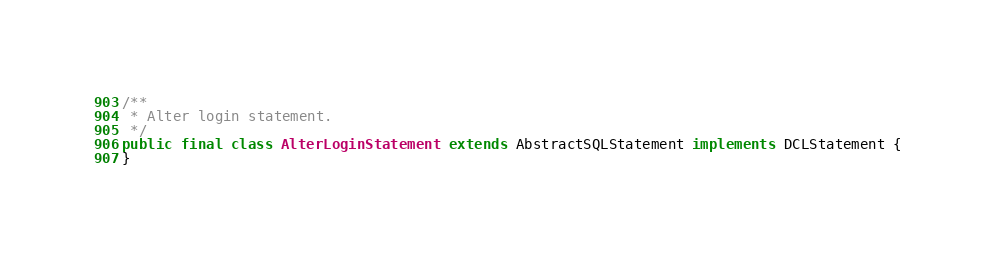<code> <loc_0><loc_0><loc_500><loc_500><_Java_>/**
 * Alter login statement.
 */
public final class AlterLoginStatement extends AbstractSQLStatement implements DCLStatement {
}
</code> 